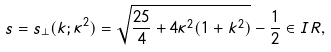Convert formula to latex. <formula><loc_0><loc_0><loc_500><loc_500>s = s _ { \perp } ( k ; \kappa ^ { 2 } ) = \sqrt { \frac { 2 5 } { 4 } + 4 \kappa ^ { 2 } ( 1 + k ^ { 2 } ) } - \frac { 1 } { 2 } \in I R ,</formula> 